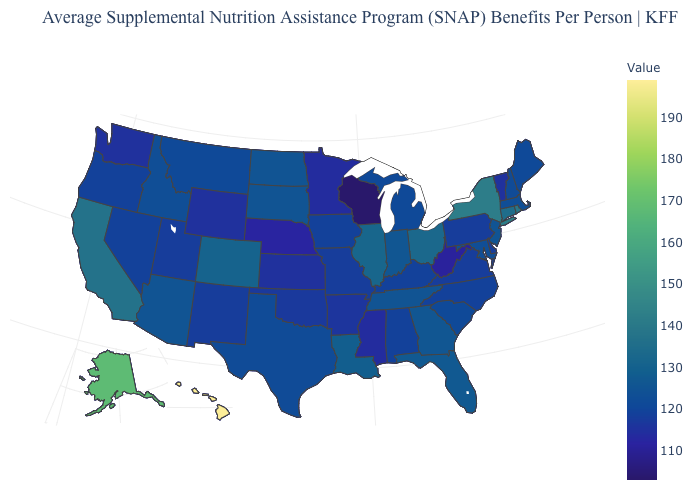Which states have the lowest value in the South?
Be succinct. West Virginia. Does Virginia have a lower value than Colorado?
Answer briefly. Yes. Does Wisconsin have the lowest value in the USA?
Answer briefly. Yes. Among the states that border Oklahoma , does Kansas have the lowest value?
Write a very short answer. Yes. Among the states that border New Mexico , does Colorado have the highest value?
Concise answer only. Yes. 